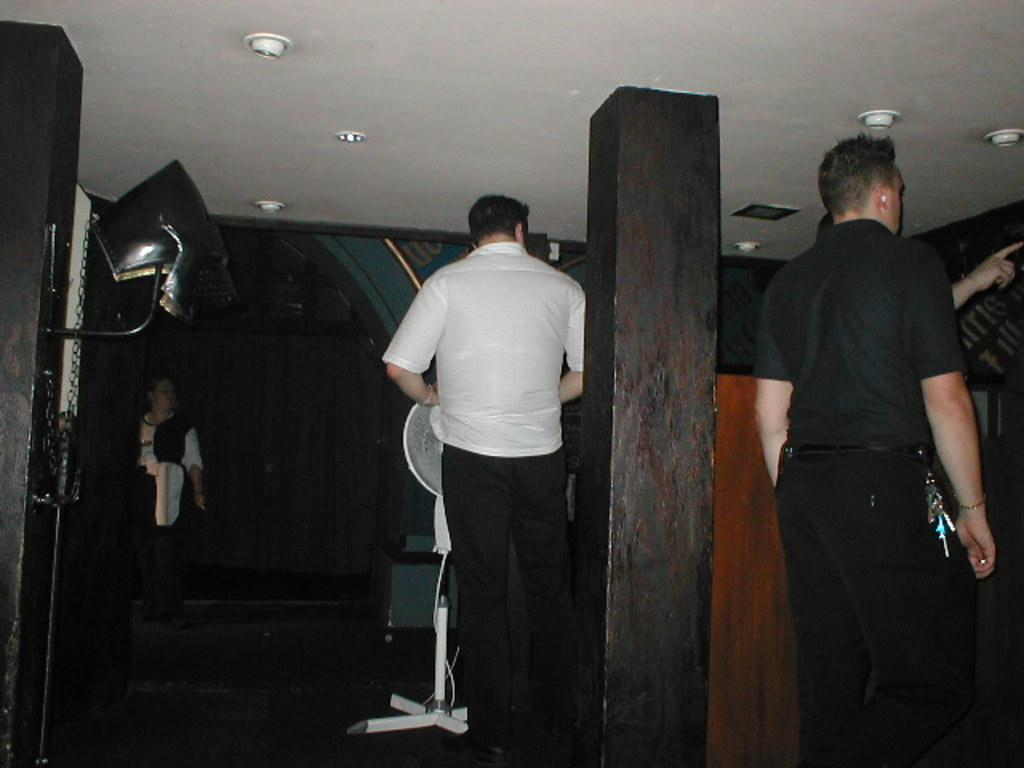How many people are in the foreground of the image? There are four persons standing in the foreground of the image. What is the surface they are standing on? The persons are standing on the floor. What architectural features can be seen in the foreground? There are pillars in the foreground of the image. What type of fan is visible in the background? There is a pedestal fan in the background of the image. What can be seen in the distance in the background? There is a rooftop visible in the background of the image. Where was the image taken? The image was taken in a hall. What time of day is it in the image, and what account is being discussed by the persons? The time of day cannot be determined from the image, and there is no mention of an account being discussed. 